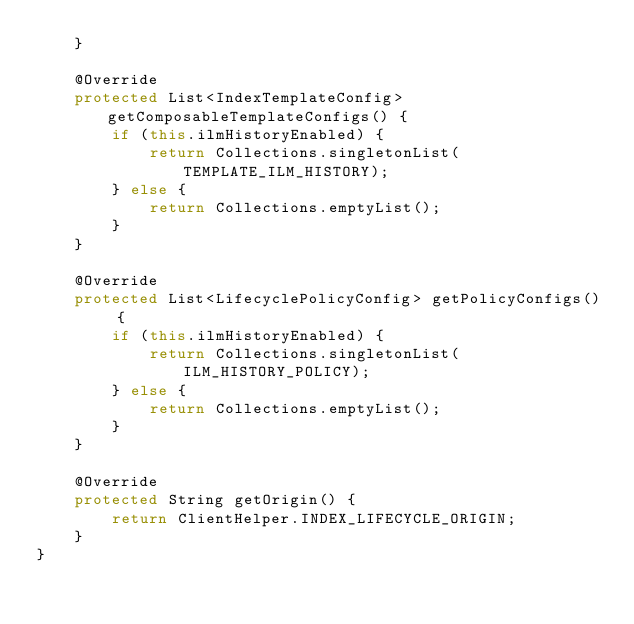Convert code to text. <code><loc_0><loc_0><loc_500><loc_500><_Java_>    }

    @Override
    protected List<IndexTemplateConfig> getComposableTemplateConfigs() {
        if (this.ilmHistoryEnabled) {
            return Collections.singletonList(TEMPLATE_ILM_HISTORY);
        } else {
            return Collections.emptyList();
        }
    }

    @Override
    protected List<LifecyclePolicyConfig> getPolicyConfigs() {
        if (this.ilmHistoryEnabled) {
            return Collections.singletonList(ILM_HISTORY_POLICY);
        } else {
            return Collections.emptyList();
        }
    }

    @Override
    protected String getOrigin() {
        return ClientHelper.INDEX_LIFECYCLE_ORIGIN;
    }
}
</code> 